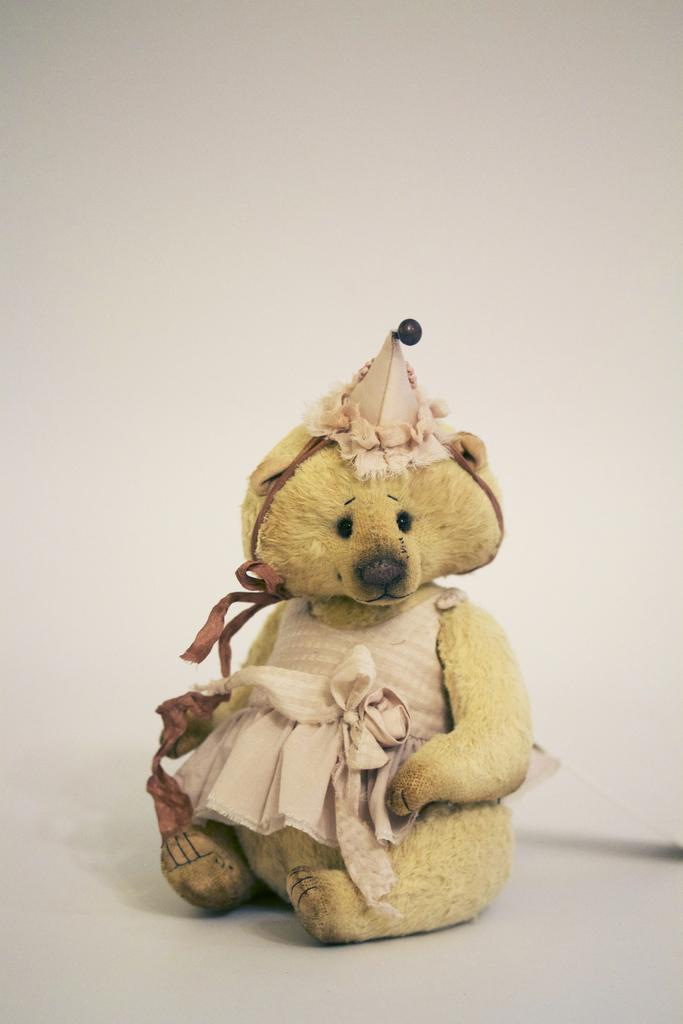What is the color of the wall in the image? The wall in the image is white. What object can be seen in the image? There is a doll in the image. How does the doll run in the image? The doll does not run in the image; it is an inanimate object. What type of veil is covering the doll in the image? There is no veil present in the image; the doll is not covered by any fabric or material. 